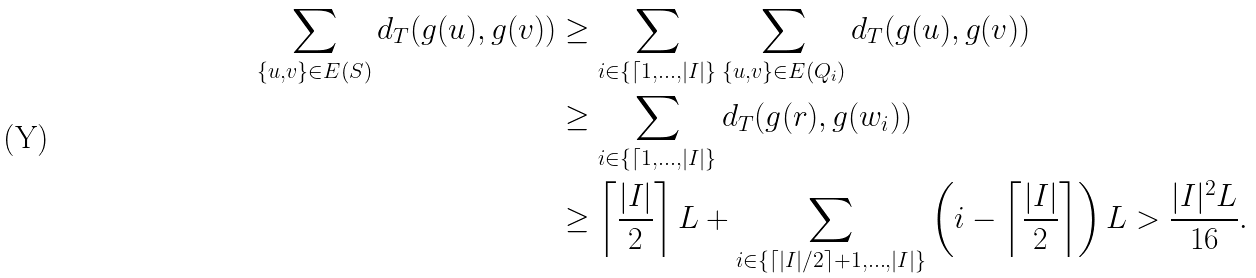Convert formula to latex. <formula><loc_0><loc_0><loc_500><loc_500>\sum _ { \{ u , v \} \in E ( S ) } d _ { T } ( g ( u ) , g ( v ) ) & \geq \sum _ { i \in \{ \lceil 1 , \dots , | I | \} } \sum _ { \{ u , v \} \in E ( Q _ { i } ) } d _ { T } ( g ( u ) , g ( v ) ) \\ & \geq \sum _ { i \in \{ \lceil 1 , \dots , | I | \} } d _ { T } ( g ( r ) , g ( w _ { i } ) ) \\ & \geq \left \lceil \frac { | I | } { 2 } \right \rceil L + \sum _ { i \in \{ \lceil | I | / 2 \rceil + 1 , \dots , | I | \} } \left ( i - \left \lceil \frac { | I | } { 2 } \right \rceil \right ) L > \frac { | I | ^ { 2 } L } { 1 6 } .</formula> 